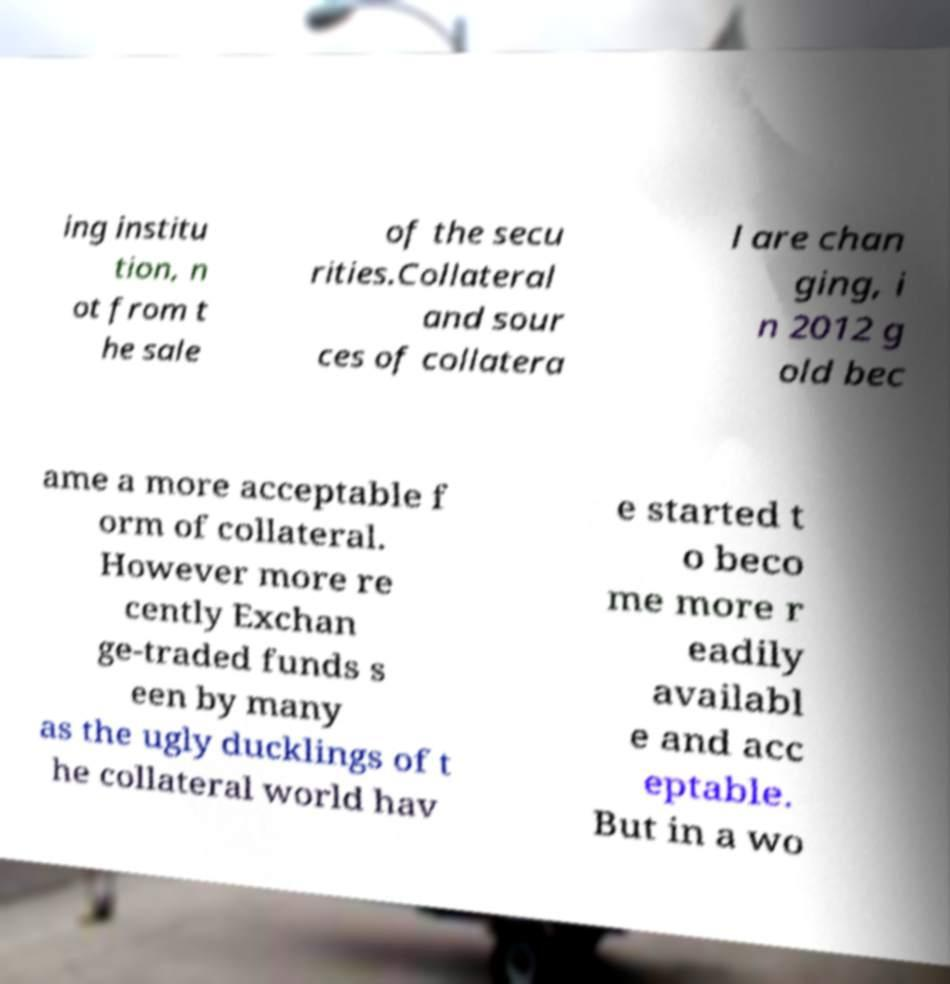Please identify and transcribe the text found in this image. ing institu tion, n ot from t he sale of the secu rities.Collateral and sour ces of collatera l are chan ging, i n 2012 g old bec ame a more acceptable f orm of collateral. However more re cently Exchan ge-traded funds s een by many as the ugly ducklings of t he collateral world hav e started t o beco me more r eadily availabl e and acc eptable. But in a wo 